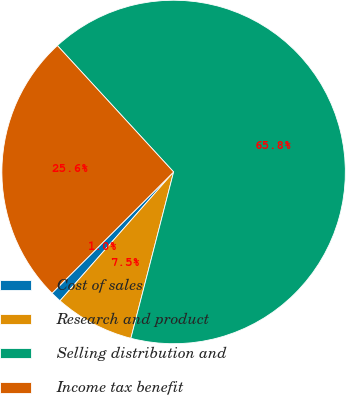<chart> <loc_0><loc_0><loc_500><loc_500><pie_chart><fcel>Cost of sales<fcel>Research and product<fcel>Selling distribution and<fcel>Income tax benefit<nl><fcel>1.02%<fcel>7.5%<fcel>65.83%<fcel>25.64%<nl></chart> 